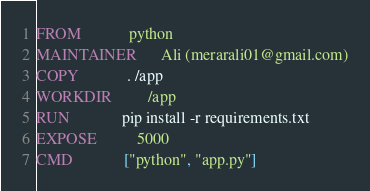<code> <loc_0><loc_0><loc_500><loc_500><_Dockerfile_>FROM            python
MAINTAINER      Ali (merarali01@gmail.com)
COPY            . /app
WORKDIR         /app
RUN             pip install -r requirements.txt
EXPOSE          5000
CMD             ["python", "app.py"]
</code> 